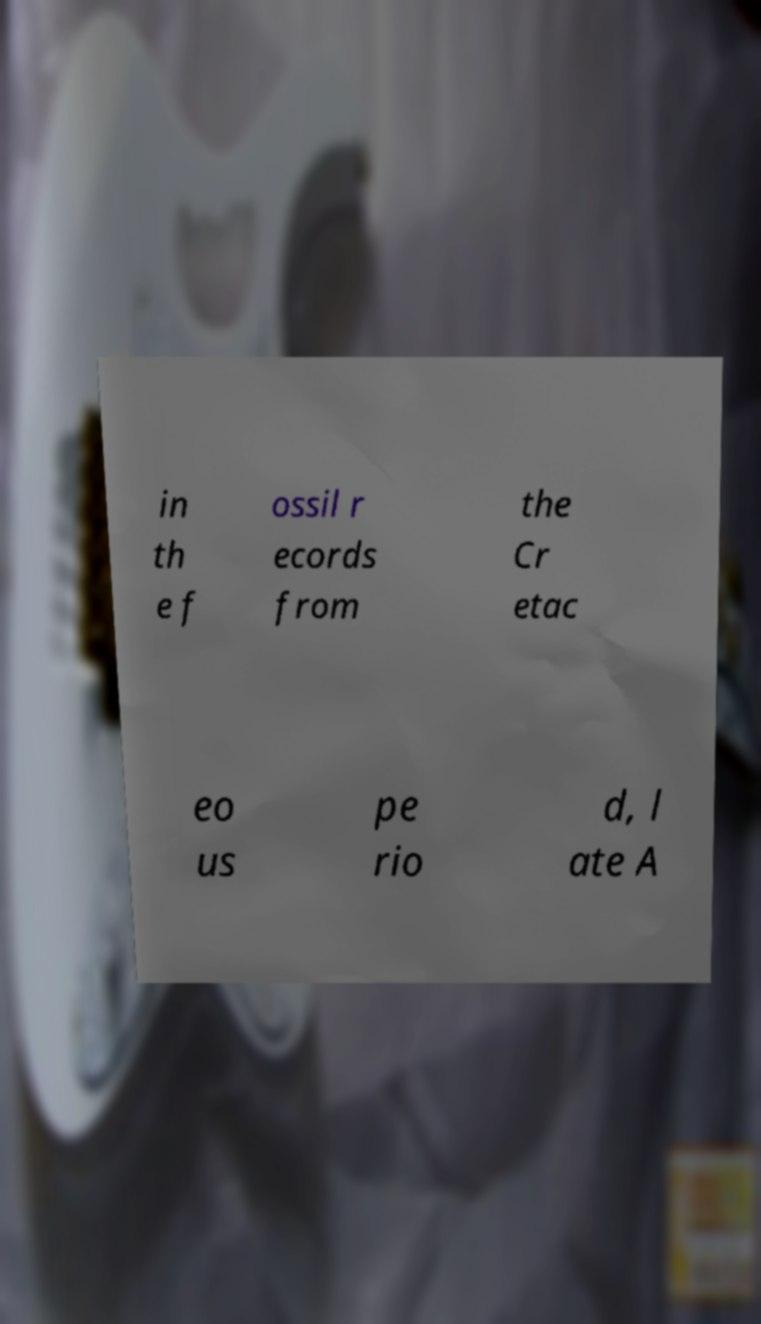I need the written content from this picture converted into text. Can you do that? in th e f ossil r ecords from the Cr etac eo us pe rio d, l ate A 